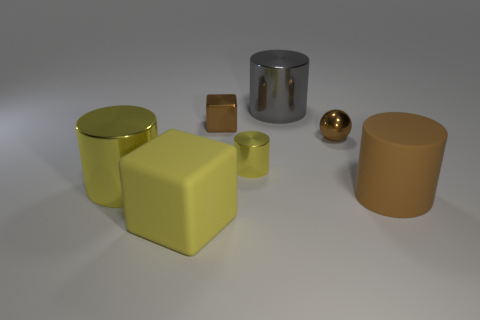Subtract all brown cylinders. How many cylinders are left? 3 Subtract all purple cylinders. Subtract all green blocks. How many cylinders are left? 4 Add 2 large yellow matte things. How many objects exist? 9 Subtract all cylinders. How many objects are left? 3 Add 2 big green metal objects. How many big green metal objects exist? 2 Subtract 0 yellow balls. How many objects are left? 7 Subtract all green cylinders. Subtract all big cylinders. How many objects are left? 4 Add 1 tiny metal cylinders. How many tiny metal cylinders are left? 2 